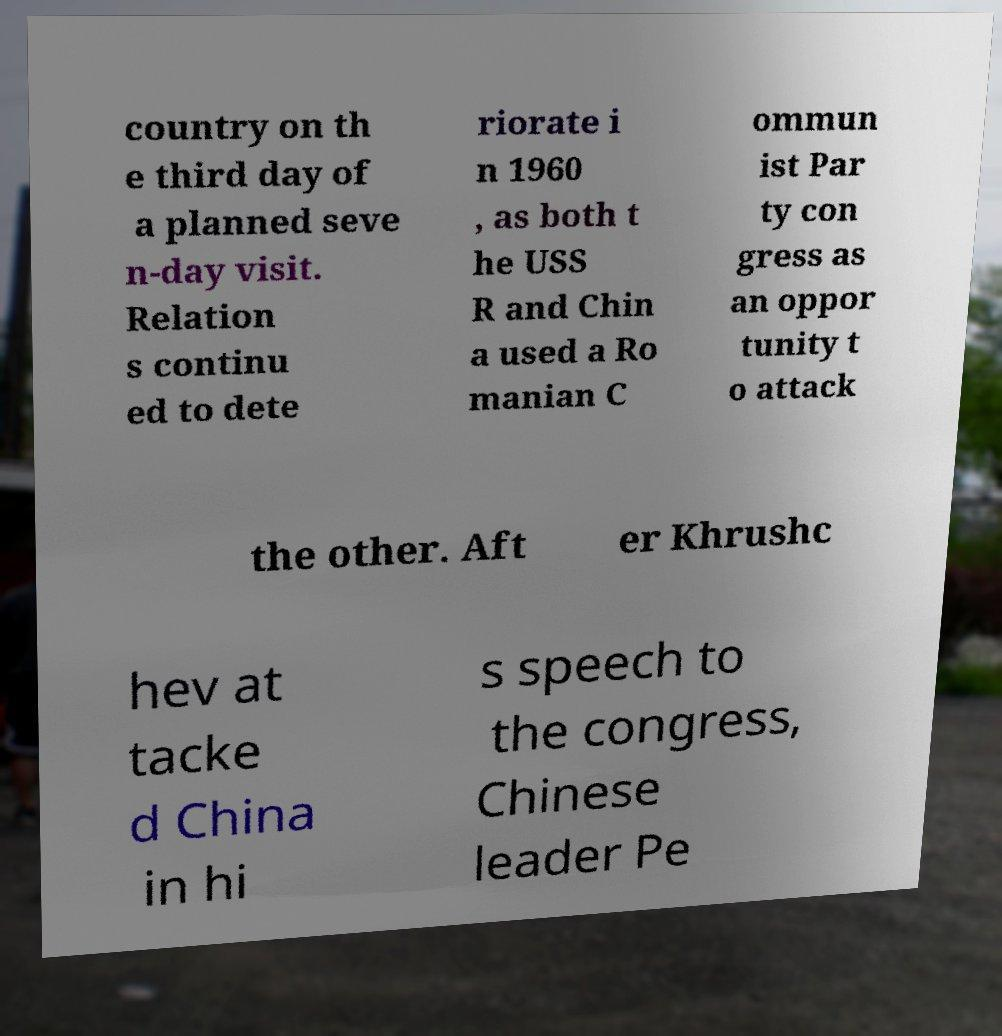Please identify and transcribe the text found in this image. country on th e third day of a planned seve n-day visit. Relation s continu ed to dete riorate i n 1960 , as both t he USS R and Chin a used a Ro manian C ommun ist Par ty con gress as an oppor tunity t o attack the other. Aft er Khrushc hev at tacke d China in hi s speech to the congress, Chinese leader Pe 